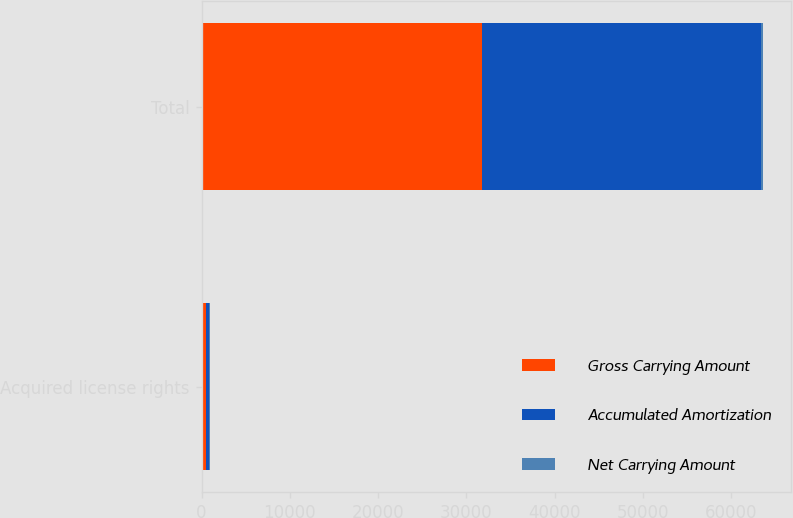<chart> <loc_0><loc_0><loc_500><loc_500><stacked_bar_chart><ecel><fcel>Acquired license rights<fcel>Total<nl><fcel>Gross Carrying Amount<fcel>490<fcel>31786<nl><fcel>Accumulated Amortization<fcel>299<fcel>31595<nl><fcel>Net Carrying Amount<fcel>191<fcel>191<nl></chart> 